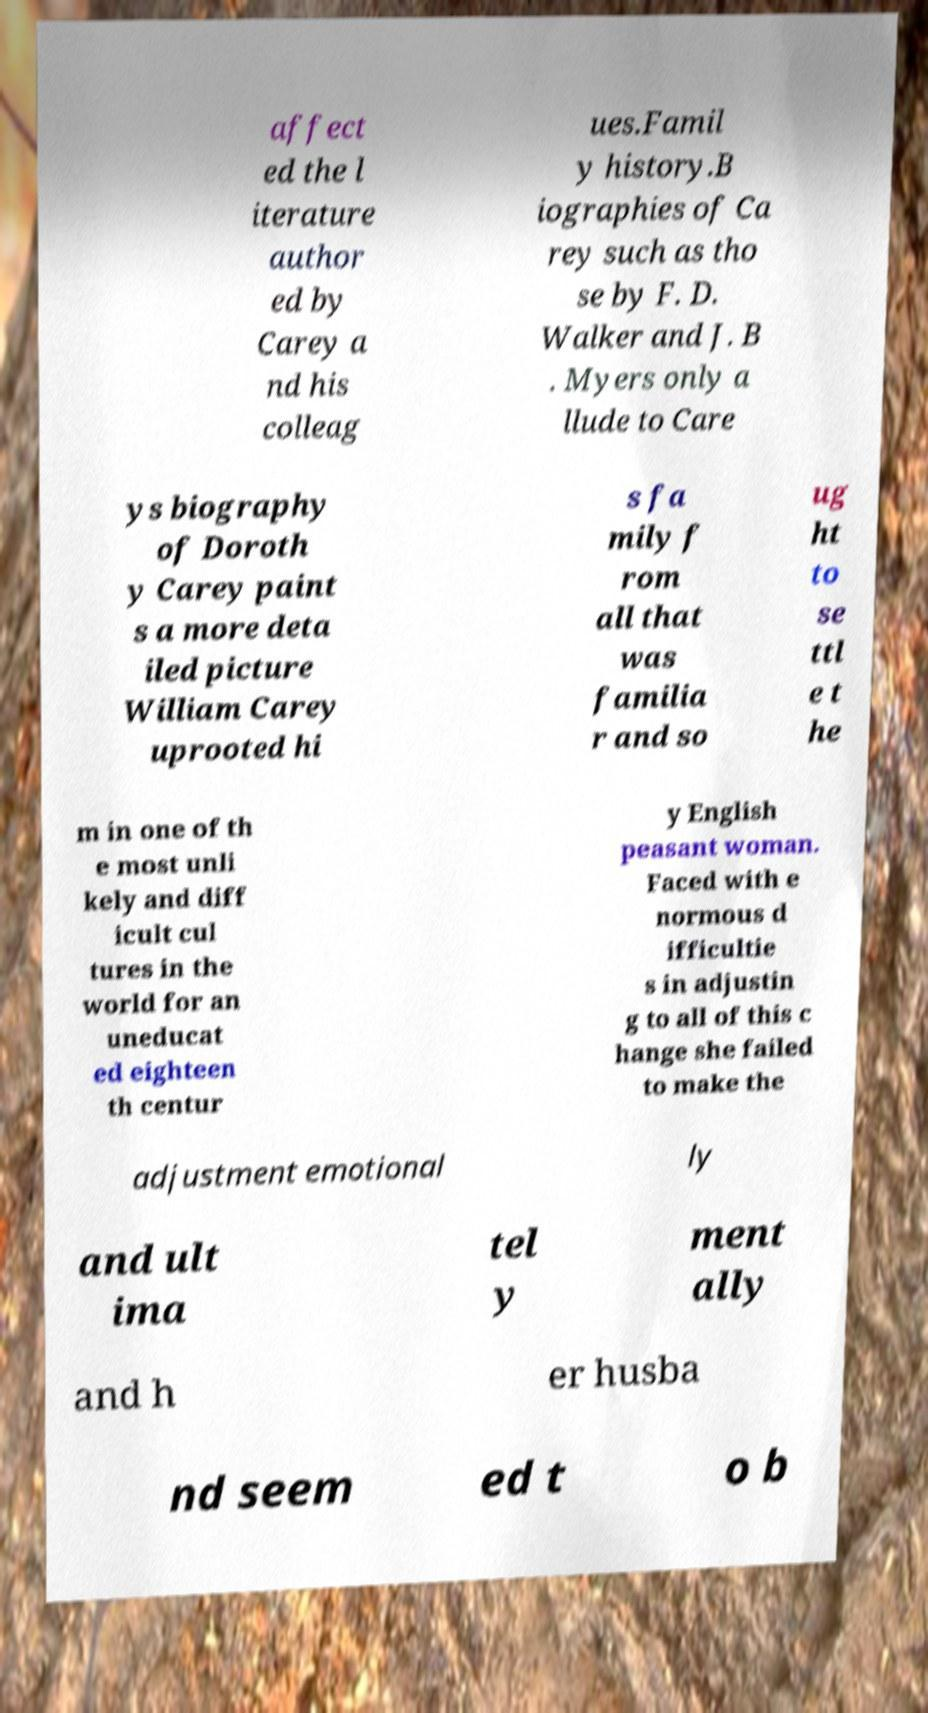For documentation purposes, I need the text within this image transcribed. Could you provide that? affect ed the l iterature author ed by Carey a nd his colleag ues.Famil y history.B iographies of Ca rey such as tho se by F. D. Walker and J. B . Myers only a llude to Care ys biography of Doroth y Carey paint s a more deta iled picture William Carey uprooted hi s fa mily f rom all that was familia r and so ug ht to se ttl e t he m in one of th e most unli kely and diff icult cul tures in the world for an uneducat ed eighteen th centur y English peasant woman. Faced with e normous d ifficultie s in adjustin g to all of this c hange she failed to make the adjustment emotional ly and ult ima tel y ment ally and h er husba nd seem ed t o b 